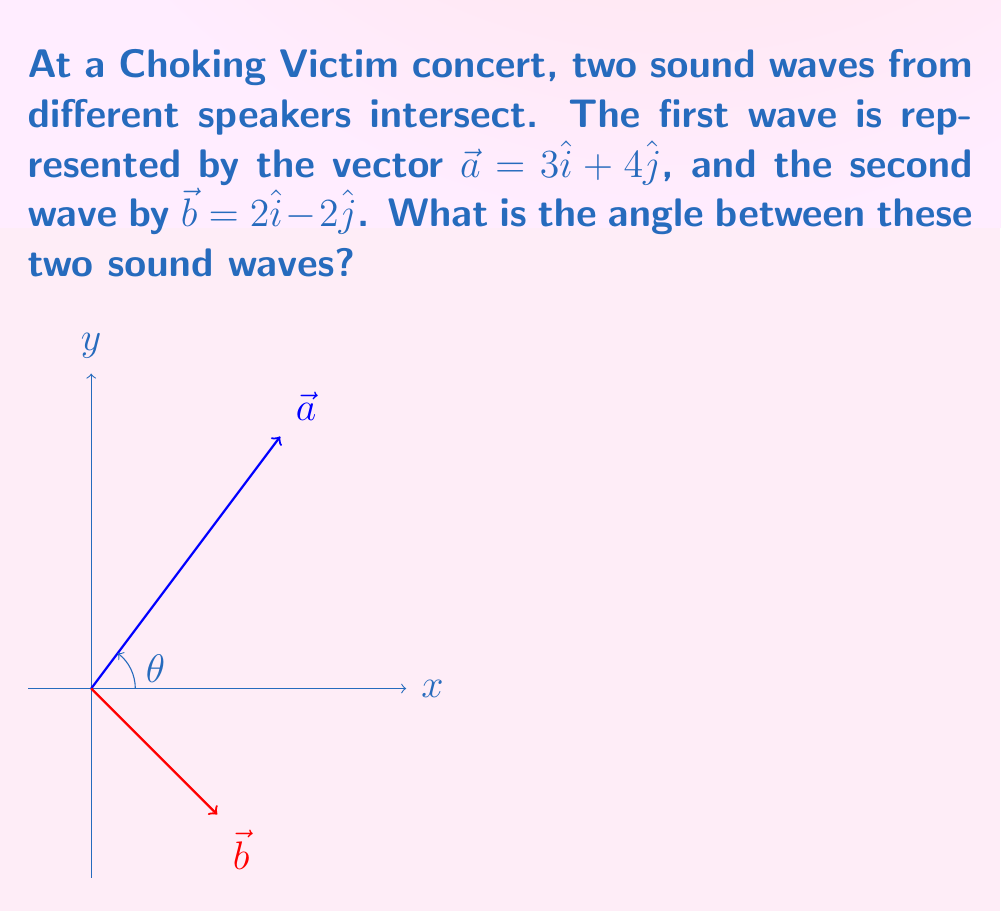Give your solution to this math problem. Let's solve this step-by-step:

1) To find the angle between two vectors, we can use the dot product formula:

   $$\cos \theta = \frac{\vec{a} \cdot \vec{b}}{|\vec{a}||\vec{b}|}$$

2) First, let's calculate the dot product $\vec{a} \cdot \vec{b}$:
   $$\vec{a} \cdot \vec{b} = (3)(2) + (4)(-2) = 6 - 8 = -2$$

3) Now, we need to calculate the magnitudes of $\vec{a}$ and $\vec{b}$:
   $$|\vec{a}| = \sqrt{3^2 + 4^2} = \sqrt{9 + 16} = \sqrt{25} = 5$$
   $$|\vec{b}| = \sqrt{2^2 + (-2)^2} = \sqrt{4 + 4} = \sqrt{8} = 2\sqrt{2}$$

4) Substituting these values into the formula:
   $$\cos \theta = \frac{-2}{5(2\sqrt{2})} = -\frac{1}{5\sqrt{2}}$$

5) To find $\theta$, we need to take the inverse cosine (arccos) of both sides:
   $$\theta = \arccos(-\frac{1}{5\sqrt{2}})$$

6) Using a calculator or computer, we can evaluate this:
   $$\theta \approx 2.0344 \text{ radians}$$

7) Converting to degrees:
   $$\theta \approx 2.0344 \times \frac{180}{\pi} \approx 116.57°$$
Answer: $116.57°$ 